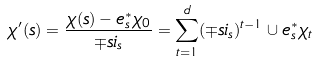<formula> <loc_0><loc_0><loc_500><loc_500>\chi ^ { \prime } ( s ) = \frac { \chi ( s ) - e _ { s } ^ { * } \chi _ { 0 } } { \mp s i _ { s } } = \sum _ { t = 1 } ^ { d } ( \mp s i _ { s } ) ^ { t - 1 } \cup e _ { s } ^ { * } \chi _ { t }</formula> 